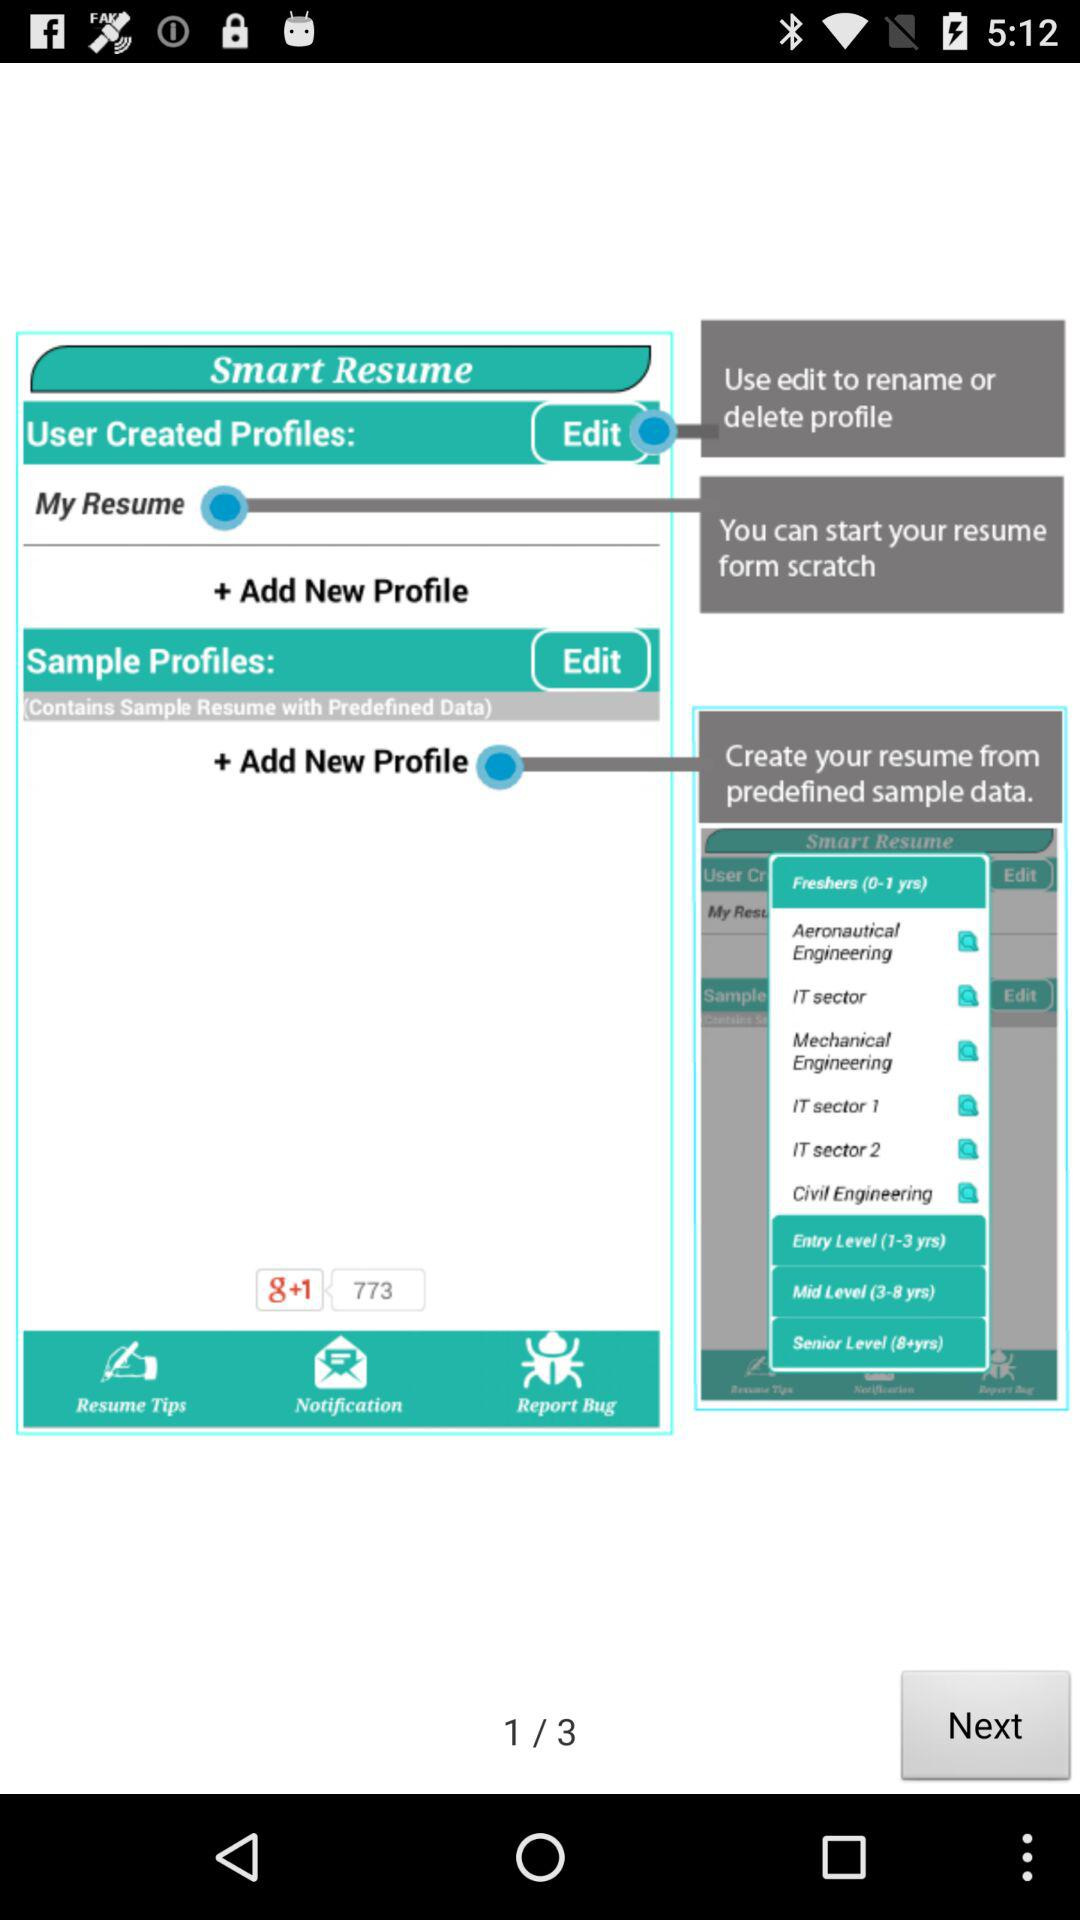On which page is the person?
When the provided information is insufficient, respond with <no answer>. <no answer> 